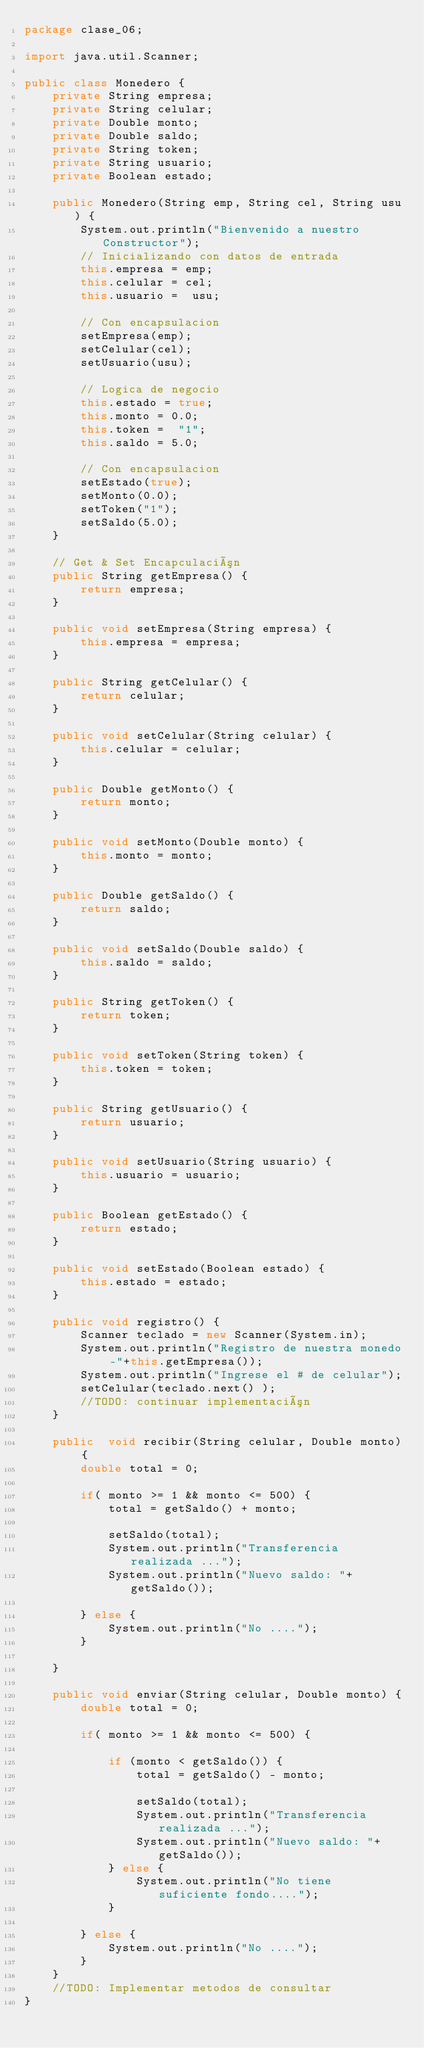<code> <loc_0><loc_0><loc_500><loc_500><_Java_>package clase_06;

import java.util.Scanner;

public class Monedero {
    private String empresa;
    private String celular;
    private Double monto;
    private Double saldo;
    private String token;
    private String usuario;
    private Boolean estado;

    public Monedero(String emp, String cel, String usu) {
        System.out.println("Bienvenido a nuestro Constructor");
        // Inicializando con datos de entrada
        this.empresa = emp;
        this.celular = cel;
        this.usuario =  usu;

        // Con encapsulacion
        setEmpresa(emp);
        setCelular(cel);
        setUsuario(usu);

        // Logica de negocio
        this.estado = true;
        this.monto = 0.0;
        this.token =  "1";
        this.saldo = 5.0;

        // Con encapsulacion
        setEstado(true);
        setMonto(0.0);
        setToken("1");
        setSaldo(5.0);
    }

    // Get & Set Encapculación
    public String getEmpresa() {
        return empresa;
    }

    public void setEmpresa(String empresa) {
        this.empresa = empresa;
    }

    public String getCelular() {
        return celular;
    }

    public void setCelular(String celular) {
        this.celular = celular;
    }

    public Double getMonto() {
        return monto;
    }

    public void setMonto(Double monto) {
        this.monto = monto;
    }

    public Double getSaldo() {
        return saldo;
    }

    public void setSaldo(Double saldo) {
        this.saldo = saldo;
    }

    public String getToken() {
        return token;
    }

    public void setToken(String token) {
        this.token = token;
    }

    public String getUsuario() {
        return usuario;
    }

    public void setUsuario(String usuario) {
        this.usuario = usuario;
    }

    public Boolean getEstado() {
        return estado;
    }

    public void setEstado(Boolean estado) {
        this.estado = estado;
    }

    public void registro() {
        Scanner teclado = new Scanner(System.in);
        System.out.println("Registro de nuestra monedo -"+this.getEmpresa());
        System.out.println("Ingrese el # de celular");
        setCelular(teclado.next() );
        //TODO: continuar implementación
    }

    public  void recibir(String celular, Double monto) {
        double total = 0;

        if( monto >= 1 && monto <= 500) {
            total = getSaldo() + monto;

            setSaldo(total);
            System.out.println("Transferencia realizada ...");
            System.out.println("Nuevo saldo: "+ getSaldo());

        } else {
            System.out.println("No ....");
        }

    }

    public void enviar(String celular, Double monto) {
        double total = 0;

        if( monto >= 1 && monto <= 500) {

            if (monto < getSaldo()) {
                total = getSaldo() - monto;

                setSaldo(total);
                System.out.println("Transferencia realizada ...");
                System.out.println("Nuevo saldo: "+ getSaldo());
            } else {
                System.out.println("No tiene suficiente fondo....");
            }

        } else {
            System.out.println("No ....");
        }
    }
    //TODO: Implementar metodos de consultar
}
</code> 